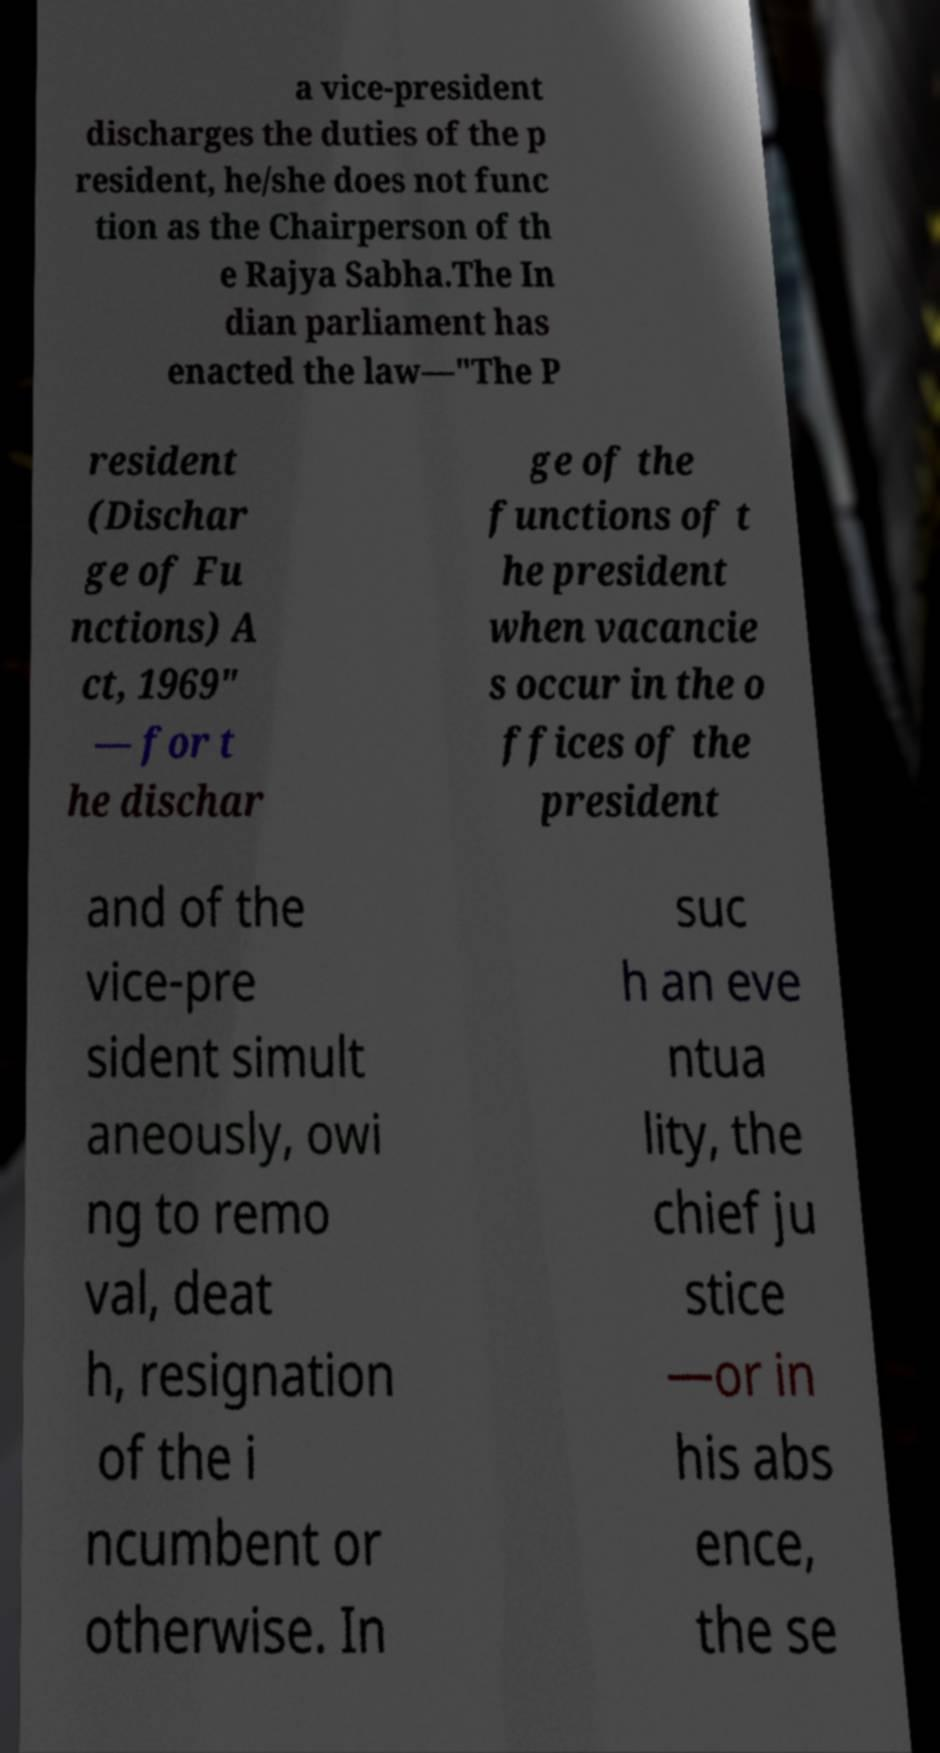Could you assist in decoding the text presented in this image and type it out clearly? a vice-president discharges the duties of the p resident, he/she does not func tion as the Chairperson of th e Rajya Sabha.The In dian parliament has enacted the law—"The P resident (Dischar ge of Fu nctions) A ct, 1969" — for t he dischar ge of the functions of t he president when vacancie s occur in the o ffices of the president and of the vice-pre sident simult aneously, owi ng to remo val, deat h, resignation of the i ncumbent or otherwise. In suc h an eve ntua lity, the chief ju stice —or in his abs ence, the se 